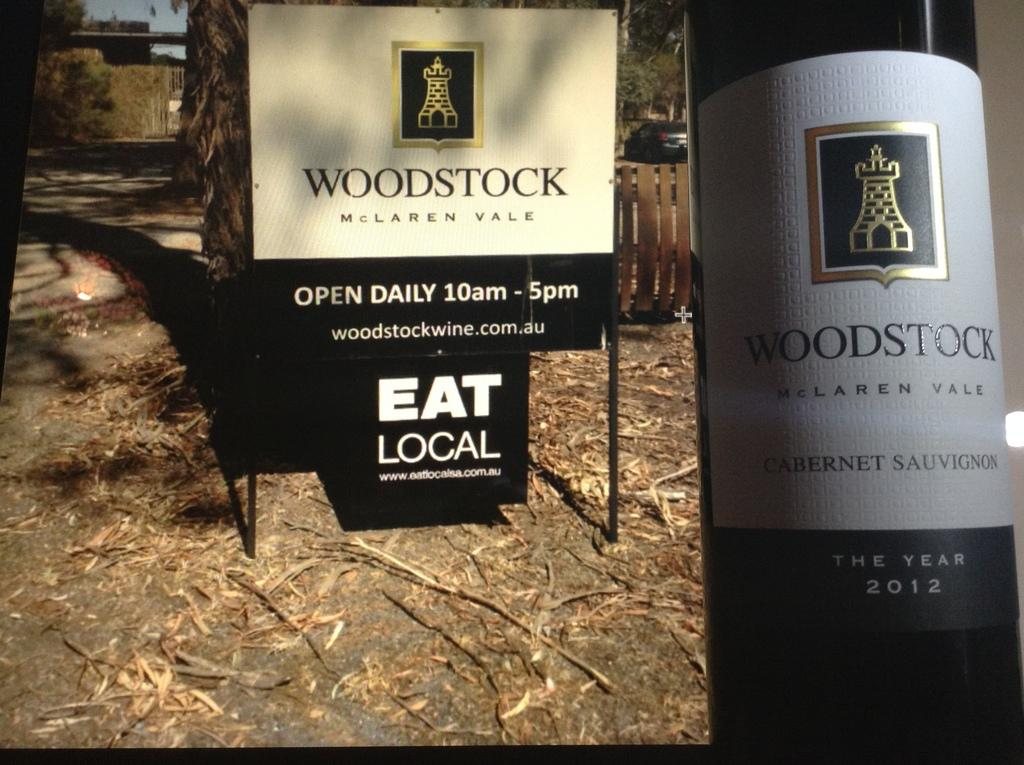<image>
Relay a brief, clear account of the picture shown. a signe for Woodstock McLaren Vale wine from 2012 